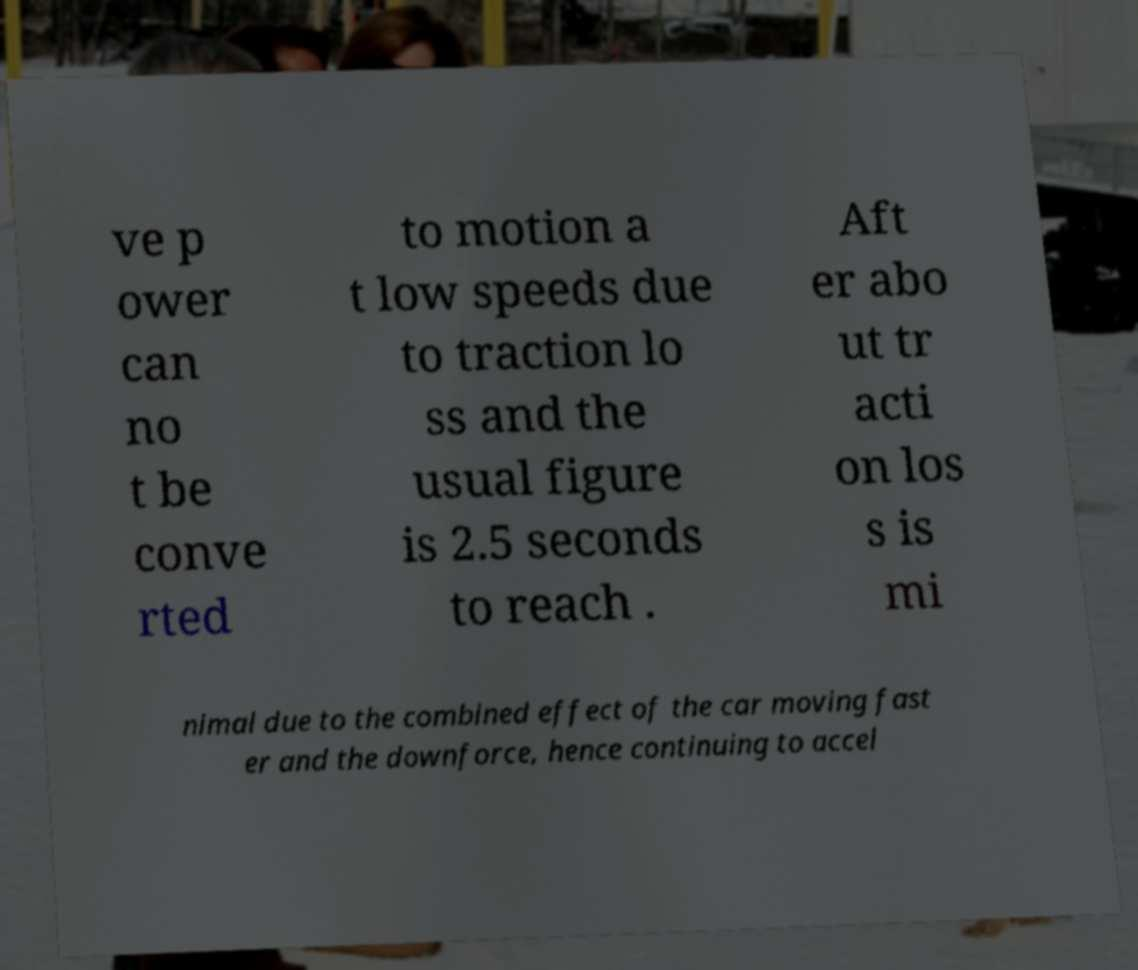There's text embedded in this image that I need extracted. Can you transcribe it verbatim? ve p ower can no t be conve rted to motion a t low speeds due to traction lo ss and the usual figure is 2.5 seconds to reach . Aft er abo ut tr acti on los s is mi nimal due to the combined effect of the car moving fast er and the downforce, hence continuing to accel 